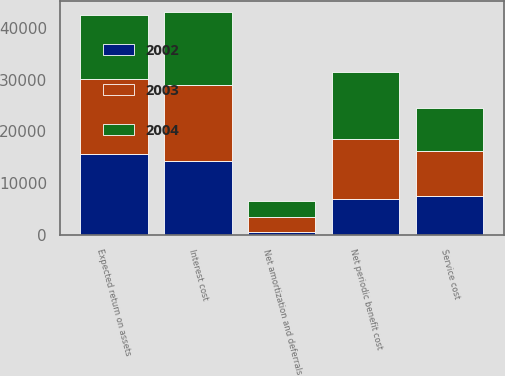<chart> <loc_0><loc_0><loc_500><loc_500><stacked_bar_chart><ecel><fcel>Service cost<fcel>Interest cost<fcel>Expected return on assets<fcel>Net amortization and deferrals<fcel>Net periodic benefit cost<nl><fcel>2003<fcel>8632<fcel>14630<fcel>14489<fcel>2750<fcel>11523<nl><fcel>2004<fcel>8263<fcel>14026<fcel>12350<fcel>3060<fcel>12999<nl><fcel>2002<fcel>7563<fcel>14320<fcel>15611<fcel>663<fcel>6935<nl></chart> 